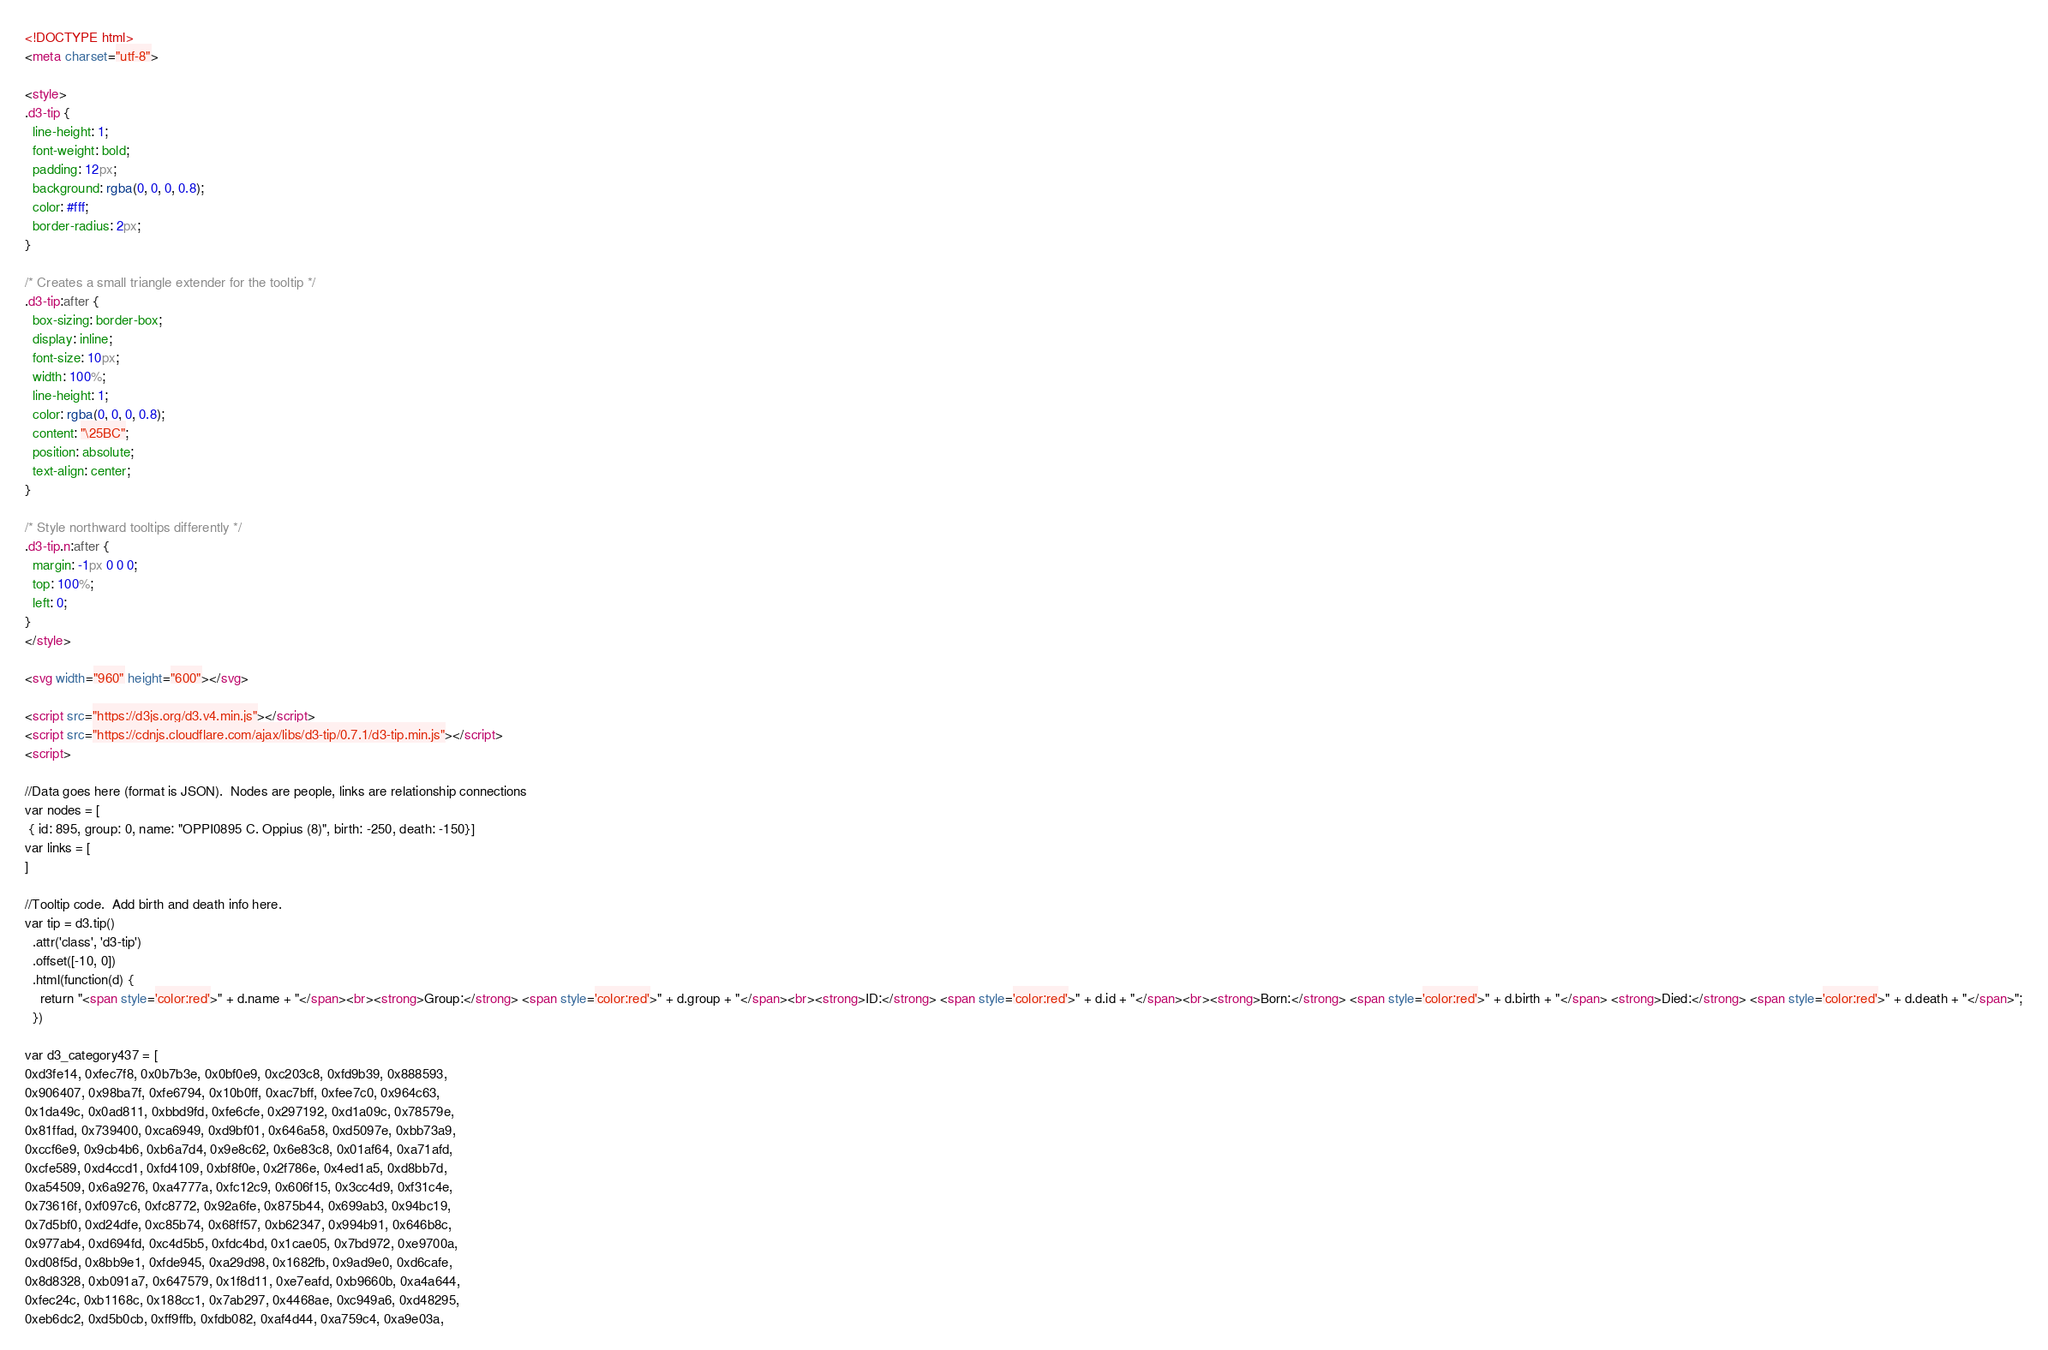<code> <loc_0><loc_0><loc_500><loc_500><_HTML_><!DOCTYPE html>
<meta charset="utf-8">

<style>
.d3-tip {
  line-height: 1;
  font-weight: bold;
  padding: 12px;
  background: rgba(0, 0, 0, 0.8);
  color: #fff;
  border-radius: 2px;
}

/* Creates a small triangle extender for the tooltip */
.d3-tip:after {
  box-sizing: border-box;
  display: inline;
  font-size: 10px;
  width: 100%;
  line-height: 1;
  color: rgba(0, 0, 0, 0.8);
  content: "\25BC";
  position: absolute;
  text-align: center;
}

/* Style northward tooltips differently */
.d3-tip.n:after {
  margin: -1px 0 0 0;
  top: 100%;
  left: 0;
}
</style>

<svg width="960" height="600"></svg>

<script src="https://d3js.org/d3.v4.min.js"></script>
<script src="https://cdnjs.cloudflare.com/ajax/libs/d3-tip/0.7.1/d3-tip.min.js"></script>
<script>

//Data goes here (format is JSON).  Nodes are people, links are relationship connections
var nodes = [
 { id: 895, group: 0, name: "OPPI0895 C. Oppius (8)", birth: -250, death: -150}]
var links = [
]

//Tooltip code.  Add birth and death info here.
var tip = d3.tip()
  .attr('class', 'd3-tip')
  .offset([-10, 0])
  .html(function(d) {
    return "<span style='color:red'>" + d.name + "</span><br><strong>Group:</strong> <span style='color:red'>" + d.group + "</span><br><strong>ID:</strong> <span style='color:red'>" + d.id + "</span><br><strong>Born:</strong> <span style='color:red'>" + d.birth + "</span> <strong>Died:</strong> <span style='color:red'>" + d.death + "</span>";
  })

var d3_category437 = [
0xd3fe14, 0xfec7f8, 0x0b7b3e, 0x0bf0e9, 0xc203c8, 0xfd9b39, 0x888593, 
0x906407, 0x98ba7f, 0xfe6794, 0x10b0ff, 0xac7bff, 0xfee7c0, 0x964c63, 
0x1da49c, 0x0ad811, 0xbbd9fd, 0xfe6cfe, 0x297192, 0xd1a09c, 0x78579e, 
0x81ffad, 0x739400, 0xca6949, 0xd9bf01, 0x646a58, 0xd5097e, 0xbb73a9, 
0xccf6e9, 0x9cb4b6, 0xb6a7d4, 0x9e8c62, 0x6e83c8, 0x01af64, 0xa71afd, 
0xcfe589, 0xd4ccd1, 0xfd4109, 0xbf8f0e, 0x2f786e, 0x4ed1a5, 0xd8bb7d, 
0xa54509, 0x6a9276, 0xa4777a, 0xfc12c9, 0x606f15, 0x3cc4d9, 0xf31c4e, 
0x73616f, 0xf097c6, 0xfc8772, 0x92a6fe, 0x875b44, 0x699ab3, 0x94bc19, 
0x7d5bf0, 0xd24dfe, 0xc85b74, 0x68ff57, 0xb62347, 0x994b91, 0x646b8c, 
0x977ab4, 0xd694fd, 0xc4d5b5, 0xfdc4bd, 0x1cae05, 0x7bd972, 0xe9700a, 
0xd08f5d, 0x8bb9e1, 0xfde945, 0xa29d98, 0x1682fb, 0x9ad9e0, 0xd6cafe, 
0x8d8328, 0xb091a7, 0x647579, 0x1f8d11, 0xe7eafd, 0xb9660b, 0xa4a644, 
0xfec24c, 0xb1168c, 0x188cc1, 0x7ab297, 0x4468ae, 0xc949a6, 0xd48295, 
0xeb6dc2, 0xd5b0cb, 0xff9ffb, 0xfdb082, 0xaf4d44, 0xa759c4, 0xa9e03a, </code> 